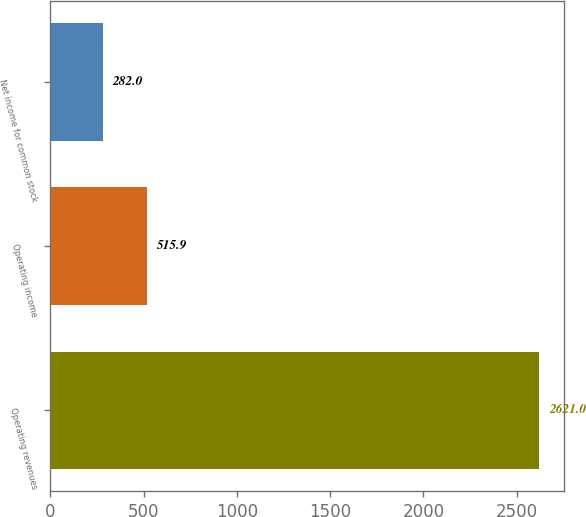Convert chart. <chart><loc_0><loc_0><loc_500><loc_500><bar_chart><fcel>Operating revenues<fcel>Operating income<fcel>Net income for common stock<nl><fcel>2621<fcel>515.9<fcel>282<nl></chart> 